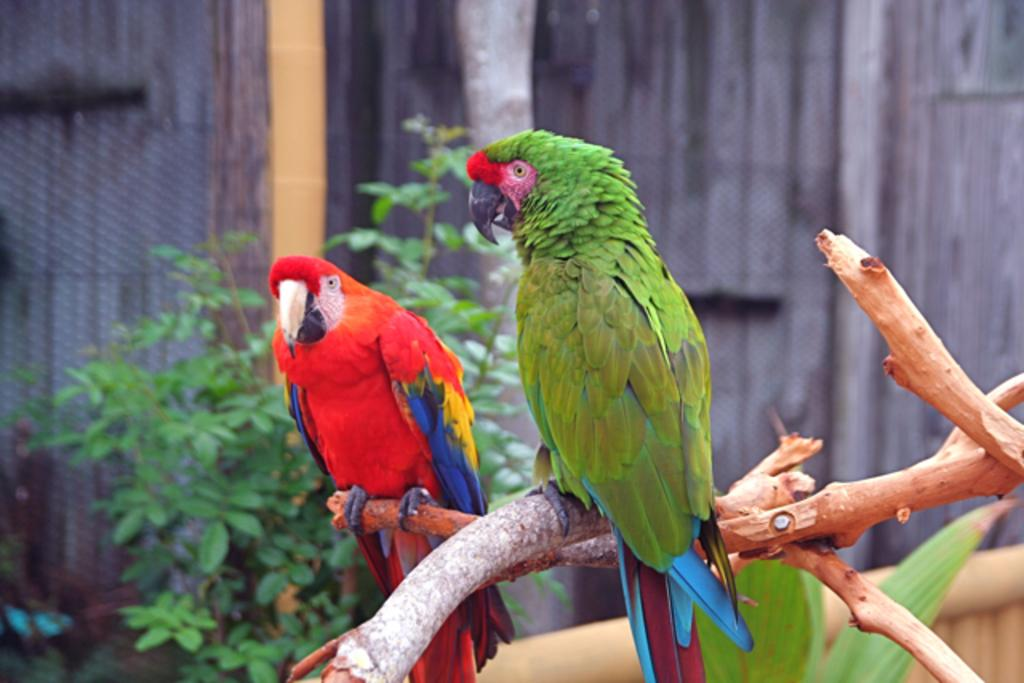How many parrots are in the image? There are two parrots in the image. Where are the parrots located? The parrots are on a branch. What can be seen in the background of the image? There is a wall, plants, and some objects in the background of the image. What type of breakfast is being served in the image? There is no breakfast present in the image; it features two parrots on a branch with a background of a wall, plants, and other objects. 